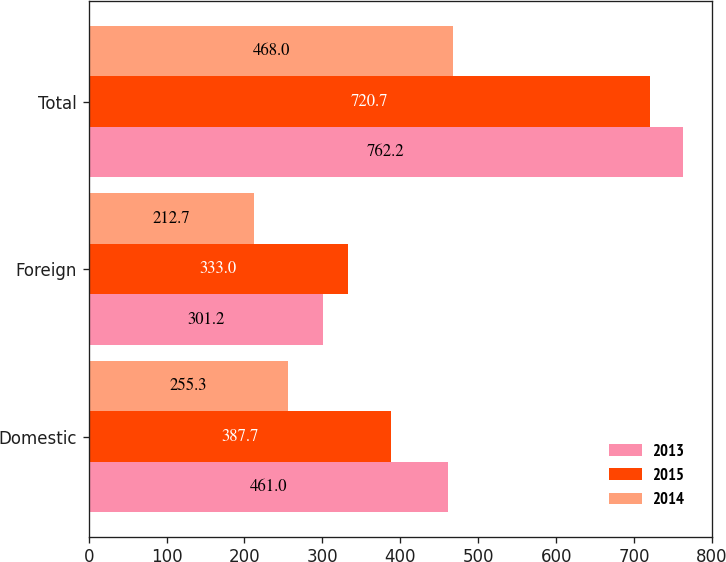Convert chart to OTSL. <chart><loc_0><loc_0><loc_500><loc_500><stacked_bar_chart><ecel><fcel>Domestic<fcel>Foreign<fcel>Total<nl><fcel>2013<fcel>461<fcel>301.2<fcel>762.2<nl><fcel>2015<fcel>387.7<fcel>333<fcel>720.7<nl><fcel>2014<fcel>255.3<fcel>212.7<fcel>468<nl></chart> 